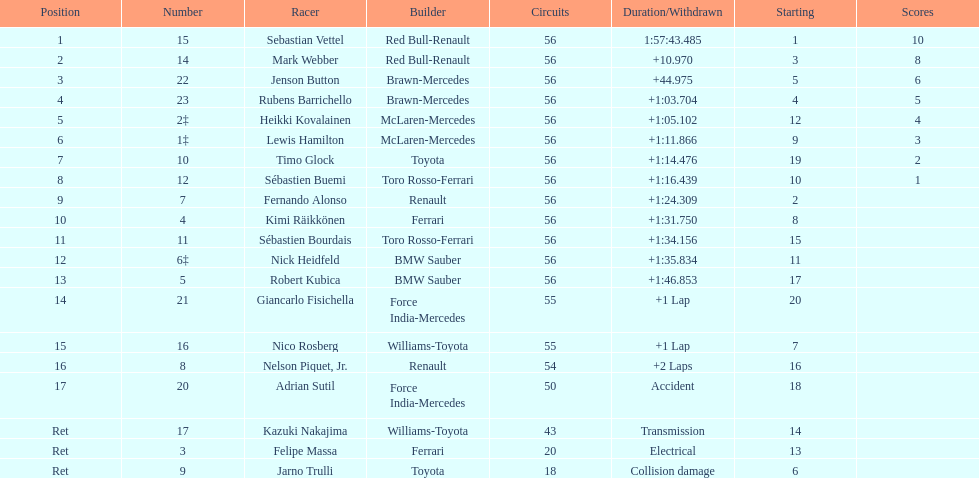Which drive retired because of electrical issues? Felipe Massa. Which driver retired due to accident? Adrian Sutil. Which driver retired due to collision damage? Jarno Trulli. 